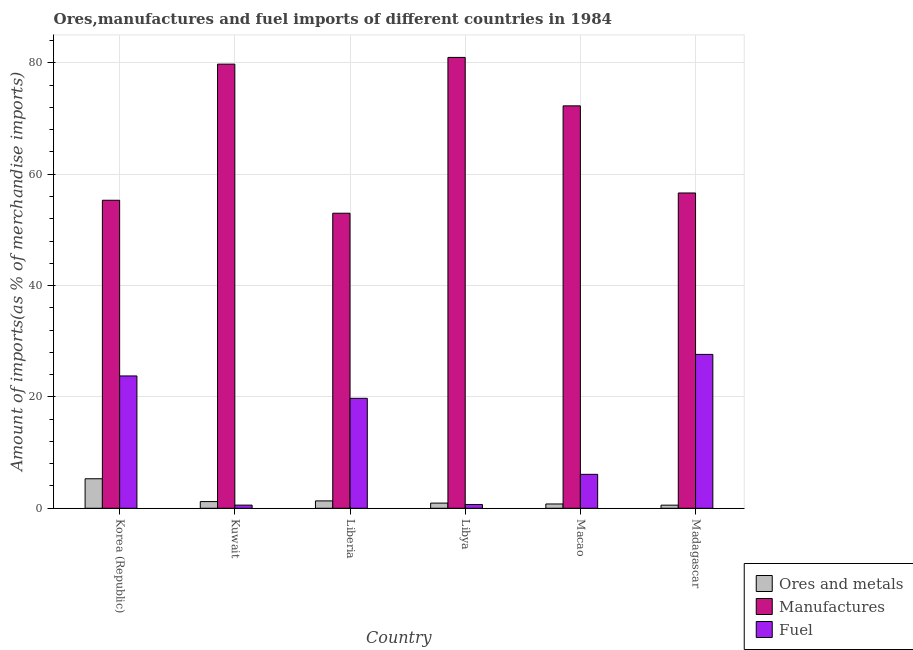Are the number of bars on each tick of the X-axis equal?
Your response must be concise. Yes. What is the label of the 4th group of bars from the left?
Offer a terse response. Libya. What is the percentage of fuel imports in Kuwait?
Your answer should be compact. 0.57. Across all countries, what is the maximum percentage of fuel imports?
Provide a short and direct response. 27.64. Across all countries, what is the minimum percentage of ores and metals imports?
Your response must be concise. 0.56. In which country was the percentage of ores and metals imports maximum?
Offer a terse response. Korea (Republic). In which country was the percentage of manufactures imports minimum?
Provide a short and direct response. Liberia. What is the total percentage of fuel imports in the graph?
Offer a very short reply. 78.48. What is the difference between the percentage of ores and metals imports in Korea (Republic) and that in Liberia?
Provide a short and direct response. 3.98. What is the difference between the percentage of fuel imports in Macao and the percentage of ores and metals imports in Madagascar?
Make the answer very short. 5.54. What is the average percentage of fuel imports per country?
Give a very brief answer. 13.08. What is the difference between the percentage of fuel imports and percentage of ores and metals imports in Madagascar?
Provide a short and direct response. 27.08. In how many countries, is the percentage of fuel imports greater than 56 %?
Ensure brevity in your answer.  0. What is the ratio of the percentage of manufactures imports in Liberia to that in Madagascar?
Provide a short and direct response. 0.94. What is the difference between the highest and the second highest percentage of fuel imports?
Give a very brief answer. 3.87. What is the difference between the highest and the lowest percentage of fuel imports?
Ensure brevity in your answer.  27.07. In how many countries, is the percentage of ores and metals imports greater than the average percentage of ores and metals imports taken over all countries?
Provide a short and direct response. 1. What does the 3rd bar from the left in Korea (Republic) represents?
Make the answer very short. Fuel. What does the 2nd bar from the right in Korea (Republic) represents?
Offer a very short reply. Manufactures. What is the difference between two consecutive major ticks on the Y-axis?
Your response must be concise. 20. Are the values on the major ticks of Y-axis written in scientific E-notation?
Keep it short and to the point. No. Does the graph contain grids?
Your answer should be compact. Yes. Where does the legend appear in the graph?
Give a very brief answer. Bottom right. How many legend labels are there?
Your response must be concise. 3. How are the legend labels stacked?
Provide a short and direct response. Vertical. What is the title of the graph?
Provide a succinct answer. Ores,manufactures and fuel imports of different countries in 1984. Does "Ages 20-60" appear as one of the legend labels in the graph?
Offer a terse response. No. What is the label or title of the Y-axis?
Make the answer very short. Amount of imports(as % of merchandise imports). What is the Amount of imports(as % of merchandise imports) in Ores and metals in Korea (Republic)?
Make the answer very short. 5.3. What is the Amount of imports(as % of merchandise imports) in Manufactures in Korea (Republic)?
Provide a succinct answer. 55.32. What is the Amount of imports(as % of merchandise imports) of Fuel in Korea (Republic)?
Provide a short and direct response. 23.77. What is the Amount of imports(as % of merchandise imports) in Ores and metals in Kuwait?
Keep it short and to the point. 1.2. What is the Amount of imports(as % of merchandise imports) in Manufactures in Kuwait?
Offer a terse response. 79.77. What is the Amount of imports(as % of merchandise imports) of Fuel in Kuwait?
Your answer should be compact. 0.57. What is the Amount of imports(as % of merchandise imports) of Ores and metals in Liberia?
Your answer should be very brief. 1.32. What is the Amount of imports(as % of merchandise imports) of Manufactures in Liberia?
Offer a terse response. 52.99. What is the Amount of imports(as % of merchandise imports) in Fuel in Liberia?
Your answer should be very brief. 19.75. What is the Amount of imports(as % of merchandise imports) of Ores and metals in Libya?
Offer a terse response. 0.93. What is the Amount of imports(as % of merchandise imports) of Manufactures in Libya?
Your response must be concise. 80.97. What is the Amount of imports(as % of merchandise imports) of Fuel in Libya?
Ensure brevity in your answer.  0.67. What is the Amount of imports(as % of merchandise imports) in Ores and metals in Macao?
Your answer should be very brief. 0.77. What is the Amount of imports(as % of merchandise imports) in Manufactures in Macao?
Make the answer very short. 72.27. What is the Amount of imports(as % of merchandise imports) in Fuel in Macao?
Provide a short and direct response. 6.1. What is the Amount of imports(as % of merchandise imports) of Ores and metals in Madagascar?
Make the answer very short. 0.56. What is the Amount of imports(as % of merchandise imports) of Manufactures in Madagascar?
Your answer should be very brief. 56.63. What is the Amount of imports(as % of merchandise imports) in Fuel in Madagascar?
Ensure brevity in your answer.  27.64. Across all countries, what is the maximum Amount of imports(as % of merchandise imports) in Ores and metals?
Offer a terse response. 5.3. Across all countries, what is the maximum Amount of imports(as % of merchandise imports) in Manufactures?
Keep it short and to the point. 80.97. Across all countries, what is the maximum Amount of imports(as % of merchandise imports) in Fuel?
Provide a short and direct response. 27.64. Across all countries, what is the minimum Amount of imports(as % of merchandise imports) of Ores and metals?
Make the answer very short. 0.56. Across all countries, what is the minimum Amount of imports(as % of merchandise imports) of Manufactures?
Your response must be concise. 52.99. Across all countries, what is the minimum Amount of imports(as % of merchandise imports) of Fuel?
Offer a very short reply. 0.57. What is the total Amount of imports(as % of merchandise imports) of Ores and metals in the graph?
Ensure brevity in your answer.  10.08. What is the total Amount of imports(as % of merchandise imports) of Manufactures in the graph?
Keep it short and to the point. 397.95. What is the total Amount of imports(as % of merchandise imports) of Fuel in the graph?
Provide a succinct answer. 78.48. What is the difference between the Amount of imports(as % of merchandise imports) of Ores and metals in Korea (Republic) and that in Kuwait?
Make the answer very short. 4.1. What is the difference between the Amount of imports(as % of merchandise imports) of Manufactures in Korea (Republic) and that in Kuwait?
Offer a terse response. -24.45. What is the difference between the Amount of imports(as % of merchandise imports) in Fuel in Korea (Republic) and that in Kuwait?
Your answer should be very brief. 23.2. What is the difference between the Amount of imports(as % of merchandise imports) in Ores and metals in Korea (Republic) and that in Liberia?
Provide a short and direct response. 3.98. What is the difference between the Amount of imports(as % of merchandise imports) in Manufactures in Korea (Republic) and that in Liberia?
Offer a terse response. 2.33. What is the difference between the Amount of imports(as % of merchandise imports) in Fuel in Korea (Republic) and that in Liberia?
Ensure brevity in your answer.  4.02. What is the difference between the Amount of imports(as % of merchandise imports) in Ores and metals in Korea (Republic) and that in Libya?
Ensure brevity in your answer.  4.37. What is the difference between the Amount of imports(as % of merchandise imports) of Manufactures in Korea (Republic) and that in Libya?
Your answer should be very brief. -25.65. What is the difference between the Amount of imports(as % of merchandise imports) in Fuel in Korea (Republic) and that in Libya?
Offer a very short reply. 23.09. What is the difference between the Amount of imports(as % of merchandise imports) of Ores and metals in Korea (Republic) and that in Macao?
Your answer should be compact. 4.53. What is the difference between the Amount of imports(as % of merchandise imports) of Manufactures in Korea (Republic) and that in Macao?
Ensure brevity in your answer.  -16.95. What is the difference between the Amount of imports(as % of merchandise imports) of Fuel in Korea (Republic) and that in Macao?
Offer a very short reply. 17.67. What is the difference between the Amount of imports(as % of merchandise imports) of Ores and metals in Korea (Republic) and that in Madagascar?
Offer a terse response. 4.74. What is the difference between the Amount of imports(as % of merchandise imports) in Manufactures in Korea (Republic) and that in Madagascar?
Offer a very short reply. -1.31. What is the difference between the Amount of imports(as % of merchandise imports) in Fuel in Korea (Republic) and that in Madagascar?
Offer a terse response. -3.87. What is the difference between the Amount of imports(as % of merchandise imports) in Ores and metals in Kuwait and that in Liberia?
Provide a short and direct response. -0.12. What is the difference between the Amount of imports(as % of merchandise imports) of Manufactures in Kuwait and that in Liberia?
Provide a short and direct response. 26.78. What is the difference between the Amount of imports(as % of merchandise imports) in Fuel in Kuwait and that in Liberia?
Make the answer very short. -19.18. What is the difference between the Amount of imports(as % of merchandise imports) of Ores and metals in Kuwait and that in Libya?
Your answer should be very brief. 0.27. What is the difference between the Amount of imports(as % of merchandise imports) in Manufactures in Kuwait and that in Libya?
Your answer should be compact. -1.21. What is the difference between the Amount of imports(as % of merchandise imports) of Fuel in Kuwait and that in Libya?
Keep it short and to the point. -0.1. What is the difference between the Amount of imports(as % of merchandise imports) of Ores and metals in Kuwait and that in Macao?
Provide a short and direct response. 0.43. What is the difference between the Amount of imports(as % of merchandise imports) in Manufactures in Kuwait and that in Macao?
Provide a succinct answer. 7.49. What is the difference between the Amount of imports(as % of merchandise imports) of Fuel in Kuwait and that in Macao?
Make the answer very short. -5.53. What is the difference between the Amount of imports(as % of merchandise imports) of Ores and metals in Kuwait and that in Madagascar?
Give a very brief answer. 0.64. What is the difference between the Amount of imports(as % of merchandise imports) of Manufactures in Kuwait and that in Madagascar?
Your answer should be compact. 23.14. What is the difference between the Amount of imports(as % of merchandise imports) of Fuel in Kuwait and that in Madagascar?
Make the answer very short. -27.07. What is the difference between the Amount of imports(as % of merchandise imports) of Ores and metals in Liberia and that in Libya?
Offer a terse response. 0.4. What is the difference between the Amount of imports(as % of merchandise imports) in Manufactures in Liberia and that in Libya?
Provide a short and direct response. -27.98. What is the difference between the Amount of imports(as % of merchandise imports) of Fuel in Liberia and that in Libya?
Provide a short and direct response. 19.08. What is the difference between the Amount of imports(as % of merchandise imports) in Ores and metals in Liberia and that in Macao?
Provide a succinct answer. 0.55. What is the difference between the Amount of imports(as % of merchandise imports) in Manufactures in Liberia and that in Macao?
Your response must be concise. -19.28. What is the difference between the Amount of imports(as % of merchandise imports) in Fuel in Liberia and that in Macao?
Offer a terse response. 13.65. What is the difference between the Amount of imports(as % of merchandise imports) of Ores and metals in Liberia and that in Madagascar?
Provide a succinct answer. 0.77. What is the difference between the Amount of imports(as % of merchandise imports) of Manufactures in Liberia and that in Madagascar?
Offer a very short reply. -3.64. What is the difference between the Amount of imports(as % of merchandise imports) in Fuel in Liberia and that in Madagascar?
Give a very brief answer. -7.89. What is the difference between the Amount of imports(as % of merchandise imports) in Ores and metals in Libya and that in Macao?
Provide a succinct answer. 0.16. What is the difference between the Amount of imports(as % of merchandise imports) of Manufactures in Libya and that in Macao?
Your response must be concise. 8.7. What is the difference between the Amount of imports(as % of merchandise imports) of Fuel in Libya and that in Macao?
Give a very brief answer. -5.42. What is the difference between the Amount of imports(as % of merchandise imports) of Ores and metals in Libya and that in Madagascar?
Provide a succinct answer. 0.37. What is the difference between the Amount of imports(as % of merchandise imports) of Manufactures in Libya and that in Madagascar?
Offer a terse response. 24.35. What is the difference between the Amount of imports(as % of merchandise imports) in Fuel in Libya and that in Madagascar?
Keep it short and to the point. -26.96. What is the difference between the Amount of imports(as % of merchandise imports) in Ores and metals in Macao and that in Madagascar?
Provide a succinct answer. 0.21. What is the difference between the Amount of imports(as % of merchandise imports) in Manufactures in Macao and that in Madagascar?
Give a very brief answer. 15.65. What is the difference between the Amount of imports(as % of merchandise imports) of Fuel in Macao and that in Madagascar?
Offer a very short reply. -21.54. What is the difference between the Amount of imports(as % of merchandise imports) in Ores and metals in Korea (Republic) and the Amount of imports(as % of merchandise imports) in Manufactures in Kuwait?
Keep it short and to the point. -74.47. What is the difference between the Amount of imports(as % of merchandise imports) in Ores and metals in Korea (Republic) and the Amount of imports(as % of merchandise imports) in Fuel in Kuwait?
Your answer should be very brief. 4.73. What is the difference between the Amount of imports(as % of merchandise imports) of Manufactures in Korea (Republic) and the Amount of imports(as % of merchandise imports) of Fuel in Kuwait?
Provide a succinct answer. 54.75. What is the difference between the Amount of imports(as % of merchandise imports) of Ores and metals in Korea (Republic) and the Amount of imports(as % of merchandise imports) of Manufactures in Liberia?
Make the answer very short. -47.69. What is the difference between the Amount of imports(as % of merchandise imports) of Ores and metals in Korea (Republic) and the Amount of imports(as % of merchandise imports) of Fuel in Liberia?
Ensure brevity in your answer.  -14.45. What is the difference between the Amount of imports(as % of merchandise imports) of Manufactures in Korea (Republic) and the Amount of imports(as % of merchandise imports) of Fuel in Liberia?
Your answer should be compact. 35.57. What is the difference between the Amount of imports(as % of merchandise imports) in Ores and metals in Korea (Republic) and the Amount of imports(as % of merchandise imports) in Manufactures in Libya?
Your answer should be very brief. -75.67. What is the difference between the Amount of imports(as % of merchandise imports) of Ores and metals in Korea (Republic) and the Amount of imports(as % of merchandise imports) of Fuel in Libya?
Your response must be concise. 4.63. What is the difference between the Amount of imports(as % of merchandise imports) of Manufactures in Korea (Republic) and the Amount of imports(as % of merchandise imports) of Fuel in Libya?
Keep it short and to the point. 54.65. What is the difference between the Amount of imports(as % of merchandise imports) in Ores and metals in Korea (Republic) and the Amount of imports(as % of merchandise imports) in Manufactures in Macao?
Offer a terse response. -66.97. What is the difference between the Amount of imports(as % of merchandise imports) in Ores and metals in Korea (Republic) and the Amount of imports(as % of merchandise imports) in Fuel in Macao?
Ensure brevity in your answer.  -0.8. What is the difference between the Amount of imports(as % of merchandise imports) in Manufactures in Korea (Republic) and the Amount of imports(as % of merchandise imports) in Fuel in Macao?
Offer a very short reply. 49.22. What is the difference between the Amount of imports(as % of merchandise imports) of Ores and metals in Korea (Republic) and the Amount of imports(as % of merchandise imports) of Manufactures in Madagascar?
Give a very brief answer. -51.33. What is the difference between the Amount of imports(as % of merchandise imports) in Ores and metals in Korea (Republic) and the Amount of imports(as % of merchandise imports) in Fuel in Madagascar?
Your answer should be compact. -22.34. What is the difference between the Amount of imports(as % of merchandise imports) of Manufactures in Korea (Republic) and the Amount of imports(as % of merchandise imports) of Fuel in Madagascar?
Offer a terse response. 27.68. What is the difference between the Amount of imports(as % of merchandise imports) in Ores and metals in Kuwait and the Amount of imports(as % of merchandise imports) in Manufactures in Liberia?
Make the answer very short. -51.79. What is the difference between the Amount of imports(as % of merchandise imports) of Ores and metals in Kuwait and the Amount of imports(as % of merchandise imports) of Fuel in Liberia?
Provide a succinct answer. -18.55. What is the difference between the Amount of imports(as % of merchandise imports) of Manufactures in Kuwait and the Amount of imports(as % of merchandise imports) of Fuel in Liberia?
Offer a very short reply. 60.02. What is the difference between the Amount of imports(as % of merchandise imports) of Ores and metals in Kuwait and the Amount of imports(as % of merchandise imports) of Manufactures in Libya?
Give a very brief answer. -79.77. What is the difference between the Amount of imports(as % of merchandise imports) in Ores and metals in Kuwait and the Amount of imports(as % of merchandise imports) in Fuel in Libya?
Offer a very short reply. 0.53. What is the difference between the Amount of imports(as % of merchandise imports) in Manufactures in Kuwait and the Amount of imports(as % of merchandise imports) in Fuel in Libya?
Provide a succinct answer. 79.1. What is the difference between the Amount of imports(as % of merchandise imports) in Ores and metals in Kuwait and the Amount of imports(as % of merchandise imports) in Manufactures in Macao?
Give a very brief answer. -71.07. What is the difference between the Amount of imports(as % of merchandise imports) in Ores and metals in Kuwait and the Amount of imports(as % of merchandise imports) in Fuel in Macao?
Offer a very short reply. -4.89. What is the difference between the Amount of imports(as % of merchandise imports) in Manufactures in Kuwait and the Amount of imports(as % of merchandise imports) in Fuel in Macao?
Keep it short and to the point. 73.67. What is the difference between the Amount of imports(as % of merchandise imports) of Ores and metals in Kuwait and the Amount of imports(as % of merchandise imports) of Manufactures in Madagascar?
Offer a very short reply. -55.42. What is the difference between the Amount of imports(as % of merchandise imports) of Ores and metals in Kuwait and the Amount of imports(as % of merchandise imports) of Fuel in Madagascar?
Keep it short and to the point. -26.43. What is the difference between the Amount of imports(as % of merchandise imports) in Manufactures in Kuwait and the Amount of imports(as % of merchandise imports) in Fuel in Madagascar?
Offer a very short reply. 52.13. What is the difference between the Amount of imports(as % of merchandise imports) of Ores and metals in Liberia and the Amount of imports(as % of merchandise imports) of Manufactures in Libya?
Make the answer very short. -79.65. What is the difference between the Amount of imports(as % of merchandise imports) of Ores and metals in Liberia and the Amount of imports(as % of merchandise imports) of Fuel in Libya?
Your response must be concise. 0.65. What is the difference between the Amount of imports(as % of merchandise imports) in Manufactures in Liberia and the Amount of imports(as % of merchandise imports) in Fuel in Libya?
Make the answer very short. 52.32. What is the difference between the Amount of imports(as % of merchandise imports) of Ores and metals in Liberia and the Amount of imports(as % of merchandise imports) of Manufactures in Macao?
Provide a succinct answer. -70.95. What is the difference between the Amount of imports(as % of merchandise imports) of Ores and metals in Liberia and the Amount of imports(as % of merchandise imports) of Fuel in Macao?
Give a very brief answer. -4.77. What is the difference between the Amount of imports(as % of merchandise imports) of Manufactures in Liberia and the Amount of imports(as % of merchandise imports) of Fuel in Macao?
Give a very brief answer. 46.9. What is the difference between the Amount of imports(as % of merchandise imports) in Ores and metals in Liberia and the Amount of imports(as % of merchandise imports) in Manufactures in Madagascar?
Provide a succinct answer. -55.3. What is the difference between the Amount of imports(as % of merchandise imports) of Ores and metals in Liberia and the Amount of imports(as % of merchandise imports) of Fuel in Madagascar?
Give a very brief answer. -26.31. What is the difference between the Amount of imports(as % of merchandise imports) in Manufactures in Liberia and the Amount of imports(as % of merchandise imports) in Fuel in Madagascar?
Ensure brevity in your answer.  25.36. What is the difference between the Amount of imports(as % of merchandise imports) in Ores and metals in Libya and the Amount of imports(as % of merchandise imports) in Manufactures in Macao?
Ensure brevity in your answer.  -71.35. What is the difference between the Amount of imports(as % of merchandise imports) in Ores and metals in Libya and the Amount of imports(as % of merchandise imports) in Fuel in Macao?
Offer a terse response. -5.17. What is the difference between the Amount of imports(as % of merchandise imports) in Manufactures in Libya and the Amount of imports(as % of merchandise imports) in Fuel in Macao?
Make the answer very short. 74.88. What is the difference between the Amount of imports(as % of merchandise imports) of Ores and metals in Libya and the Amount of imports(as % of merchandise imports) of Manufactures in Madagascar?
Provide a succinct answer. -55.7. What is the difference between the Amount of imports(as % of merchandise imports) of Ores and metals in Libya and the Amount of imports(as % of merchandise imports) of Fuel in Madagascar?
Keep it short and to the point. -26.71. What is the difference between the Amount of imports(as % of merchandise imports) of Manufactures in Libya and the Amount of imports(as % of merchandise imports) of Fuel in Madagascar?
Make the answer very short. 53.34. What is the difference between the Amount of imports(as % of merchandise imports) in Ores and metals in Macao and the Amount of imports(as % of merchandise imports) in Manufactures in Madagascar?
Offer a terse response. -55.85. What is the difference between the Amount of imports(as % of merchandise imports) in Ores and metals in Macao and the Amount of imports(as % of merchandise imports) in Fuel in Madagascar?
Offer a terse response. -26.86. What is the difference between the Amount of imports(as % of merchandise imports) of Manufactures in Macao and the Amount of imports(as % of merchandise imports) of Fuel in Madagascar?
Keep it short and to the point. 44.64. What is the average Amount of imports(as % of merchandise imports) in Ores and metals per country?
Your response must be concise. 1.68. What is the average Amount of imports(as % of merchandise imports) of Manufactures per country?
Your response must be concise. 66.32. What is the average Amount of imports(as % of merchandise imports) of Fuel per country?
Your answer should be compact. 13.08. What is the difference between the Amount of imports(as % of merchandise imports) of Ores and metals and Amount of imports(as % of merchandise imports) of Manufactures in Korea (Republic)?
Provide a succinct answer. -50.02. What is the difference between the Amount of imports(as % of merchandise imports) of Ores and metals and Amount of imports(as % of merchandise imports) of Fuel in Korea (Republic)?
Your response must be concise. -18.47. What is the difference between the Amount of imports(as % of merchandise imports) of Manufactures and Amount of imports(as % of merchandise imports) of Fuel in Korea (Republic)?
Offer a terse response. 31.55. What is the difference between the Amount of imports(as % of merchandise imports) of Ores and metals and Amount of imports(as % of merchandise imports) of Manufactures in Kuwait?
Provide a succinct answer. -78.57. What is the difference between the Amount of imports(as % of merchandise imports) of Ores and metals and Amount of imports(as % of merchandise imports) of Fuel in Kuwait?
Give a very brief answer. 0.63. What is the difference between the Amount of imports(as % of merchandise imports) in Manufactures and Amount of imports(as % of merchandise imports) in Fuel in Kuwait?
Give a very brief answer. 79.2. What is the difference between the Amount of imports(as % of merchandise imports) of Ores and metals and Amount of imports(as % of merchandise imports) of Manufactures in Liberia?
Offer a very short reply. -51.67. What is the difference between the Amount of imports(as % of merchandise imports) in Ores and metals and Amount of imports(as % of merchandise imports) in Fuel in Liberia?
Offer a very short reply. -18.43. What is the difference between the Amount of imports(as % of merchandise imports) in Manufactures and Amount of imports(as % of merchandise imports) in Fuel in Liberia?
Provide a short and direct response. 33.24. What is the difference between the Amount of imports(as % of merchandise imports) of Ores and metals and Amount of imports(as % of merchandise imports) of Manufactures in Libya?
Your answer should be very brief. -80.05. What is the difference between the Amount of imports(as % of merchandise imports) in Ores and metals and Amount of imports(as % of merchandise imports) in Fuel in Libya?
Keep it short and to the point. 0.26. What is the difference between the Amount of imports(as % of merchandise imports) of Manufactures and Amount of imports(as % of merchandise imports) of Fuel in Libya?
Make the answer very short. 80.3. What is the difference between the Amount of imports(as % of merchandise imports) of Ores and metals and Amount of imports(as % of merchandise imports) of Manufactures in Macao?
Your answer should be compact. -71.5. What is the difference between the Amount of imports(as % of merchandise imports) in Ores and metals and Amount of imports(as % of merchandise imports) in Fuel in Macao?
Provide a short and direct response. -5.32. What is the difference between the Amount of imports(as % of merchandise imports) in Manufactures and Amount of imports(as % of merchandise imports) in Fuel in Macao?
Provide a succinct answer. 66.18. What is the difference between the Amount of imports(as % of merchandise imports) in Ores and metals and Amount of imports(as % of merchandise imports) in Manufactures in Madagascar?
Your answer should be very brief. -56.07. What is the difference between the Amount of imports(as % of merchandise imports) in Ores and metals and Amount of imports(as % of merchandise imports) in Fuel in Madagascar?
Keep it short and to the point. -27.08. What is the difference between the Amount of imports(as % of merchandise imports) of Manufactures and Amount of imports(as % of merchandise imports) of Fuel in Madagascar?
Keep it short and to the point. 28.99. What is the ratio of the Amount of imports(as % of merchandise imports) of Ores and metals in Korea (Republic) to that in Kuwait?
Offer a very short reply. 4.41. What is the ratio of the Amount of imports(as % of merchandise imports) of Manufactures in Korea (Republic) to that in Kuwait?
Offer a very short reply. 0.69. What is the ratio of the Amount of imports(as % of merchandise imports) of Fuel in Korea (Republic) to that in Kuwait?
Provide a succinct answer. 41.93. What is the ratio of the Amount of imports(as % of merchandise imports) of Ores and metals in Korea (Republic) to that in Liberia?
Provide a succinct answer. 4.01. What is the ratio of the Amount of imports(as % of merchandise imports) of Manufactures in Korea (Republic) to that in Liberia?
Offer a very short reply. 1.04. What is the ratio of the Amount of imports(as % of merchandise imports) in Fuel in Korea (Republic) to that in Liberia?
Your response must be concise. 1.2. What is the ratio of the Amount of imports(as % of merchandise imports) in Ores and metals in Korea (Republic) to that in Libya?
Keep it short and to the point. 5.71. What is the ratio of the Amount of imports(as % of merchandise imports) of Manufactures in Korea (Republic) to that in Libya?
Offer a very short reply. 0.68. What is the ratio of the Amount of imports(as % of merchandise imports) in Fuel in Korea (Republic) to that in Libya?
Provide a succinct answer. 35.41. What is the ratio of the Amount of imports(as % of merchandise imports) in Ores and metals in Korea (Republic) to that in Macao?
Give a very brief answer. 6.86. What is the ratio of the Amount of imports(as % of merchandise imports) of Manufactures in Korea (Republic) to that in Macao?
Your response must be concise. 0.77. What is the ratio of the Amount of imports(as % of merchandise imports) in Fuel in Korea (Republic) to that in Macao?
Provide a short and direct response. 3.9. What is the ratio of the Amount of imports(as % of merchandise imports) in Ores and metals in Korea (Republic) to that in Madagascar?
Make the answer very short. 9.51. What is the ratio of the Amount of imports(as % of merchandise imports) in Manufactures in Korea (Republic) to that in Madagascar?
Ensure brevity in your answer.  0.98. What is the ratio of the Amount of imports(as % of merchandise imports) of Fuel in Korea (Republic) to that in Madagascar?
Provide a short and direct response. 0.86. What is the ratio of the Amount of imports(as % of merchandise imports) of Ores and metals in Kuwait to that in Liberia?
Provide a succinct answer. 0.91. What is the ratio of the Amount of imports(as % of merchandise imports) in Manufactures in Kuwait to that in Liberia?
Offer a very short reply. 1.51. What is the ratio of the Amount of imports(as % of merchandise imports) in Fuel in Kuwait to that in Liberia?
Give a very brief answer. 0.03. What is the ratio of the Amount of imports(as % of merchandise imports) of Ores and metals in Kuwait to that in Libya?
Your answer should be compact. 1.3. What is the ratio of the Amount of imports(as % of merchandise imports) in Manufactures in Kuwait to that in Libya?
Your answer should be very brief. 0.99. What is the ratio of the Amount of imports(as % of merchandise imports) of Fuel in Kuwait to that in Libya?
Give a very brief answer. 0.84. What is the ratio of the Amount of imports(as % of merchandise imports) in Ores and metals in Kuwait to that in Macao?
Give a very brief answer. 1.56. What is the ratio of the Amount of imports(as % of merchandise imports) of Manufactures in Kuwait to that in Macao?
Ensure brevity in your answer.  1.1. What is the ratio of the Amount of imports(as % of merchandise imports) of Fuel in Kuwait to that in Macao?
Your answer should be compact. 0.09. What is the ratio of the Amount of imports(as % of merchandise imports) of Ores and metals in Kuwait to that in Madagascar?
Make the answer very short. 2.16. What is the ratio of the Amount of imports(as % of merchandise imports) of Manufactures in Kuwait to that in Madagascar?
Offer a very short reply. 1.41. What is the ratio of the Amount of imports(as % of merchandise imports) in Fuel in Kuwait to that in Madagascar?
Make the answer very short. 0.02. What is the ratio of the Amount of imports(as % of merchandise imports) in Ores and metals in Liberia to that in Libya?
Provide a succinct answer. 1.43. What is the ratio of the Amount of imports(as % of merchandise imports) in Manufactures in Liberia to that in Libya?
Provide a short and direct response. 0.65. What is the ratio of the Amount of imports(as % of merchandise imports) in Fuel in Liberia to that in Libya?
Ensure brevity in your answer.  29.42. What is the ratio of the Amount of imports(as % of merchandise imports) in Ores and metals in Liberia to that in Macao?
Provide a succinct answer. 1.71. What is the ratio of the Amount of imports(as % of merchandise imports) in Manufactures in Liberia to that in Macao?
Offer a terse response. 0.73. What is the ratio of the Amount of imports(as % of merchandise imports) in Fuel in Liberia to that in Macao?
Your response must be concise. 3.24. What is the ratio of the Amount of imports(as % of merchandise imports) of Ores and metals in Liberia to that in Madagascar?
Provide a succinct answer. 2.37. What is the ratio of the Amount of imports(as % of merchandise imports) of Manufactures in Liberia to that in Madagascar?
Your answer should be very brief. 0.94. What is the ratio of the Amount of imports(as % of merchandise imports) of Fuel in Liberia to that in Madagascar?
Your response must be concise. 0.71. What is the ratio of the Amount of imports(as % of merchandise imports) in Ores and metals in Libya to that in Macao?
Keep it short and to the point. 1.2. What is the ratio of the Amount of imports(as % of merchandise imports) of Manufactures in Libya to that in Macao?
Provide a short and direct response. 1.12. What is the ratio of the Amount of imports(as % of merchandise imports) of Fuel in Libya to that in Macao?
Your response must be concise. 0.11. What is the ratio of the Amount of imports(as % of merchandise imports) in Ores and metals in Libya to that in Madagascar?
Provide a short and direct response. 1.66. What is the ratio of the Amount of imports(as % of merchandise imports) of Manufactures in Libya to that in Madagascar?
Provide a succinct answer. 1.43. What is the ratio of the Amount of imports(as % of merchandise imports) in Fuel in Libya to that in Madagascar?
Keep it short and to the point. 0.02. What is the ratio of the Amount of imports(as % of merchandise imports) in Ores and metals in Macao to that in Madagascar?
Provide a succinct answer. 1.38. What is the ratio of the Amount of imports(as % of merchandise imports) in Manufactures in Macao to that in Madagascar?
Keep it short and to the point. 1.28. What is the ratio of the Amount of imports(as % of merchandise imports) in Fuel in Macao to that in Madagascar?
Your answer should be very brief. 0.22. What is the difference between the highest and the second highest Amount of imports(as % of merchandise imports) in Ores and metals?
Offer a very short reply. 3.98. What is the difference between the highest and the second highest Amount of imports(as % of merchandise imports) of Manufactures?
Make the answer very short. 1.21. What is the difference between the highest and the second highest Amount of imports(as % of merchandise imports) in Fuel?
Provide a succinct answer. 3.87. What is the difference between the highest and the lowest Amount of imports(as % of merchandise imports) in Ores and metals?
Give a very brief answer. 4.74. What is the difference between the highest and the lowest Amount of imports(as % of merchandise imports) in Manufactures?
Offer a very short reply. 27.98. What is the difference between the highest and the lowest Amount of imports(as % of merchandise imports) of Fuel?
Offer a very short reply. 27.07. 